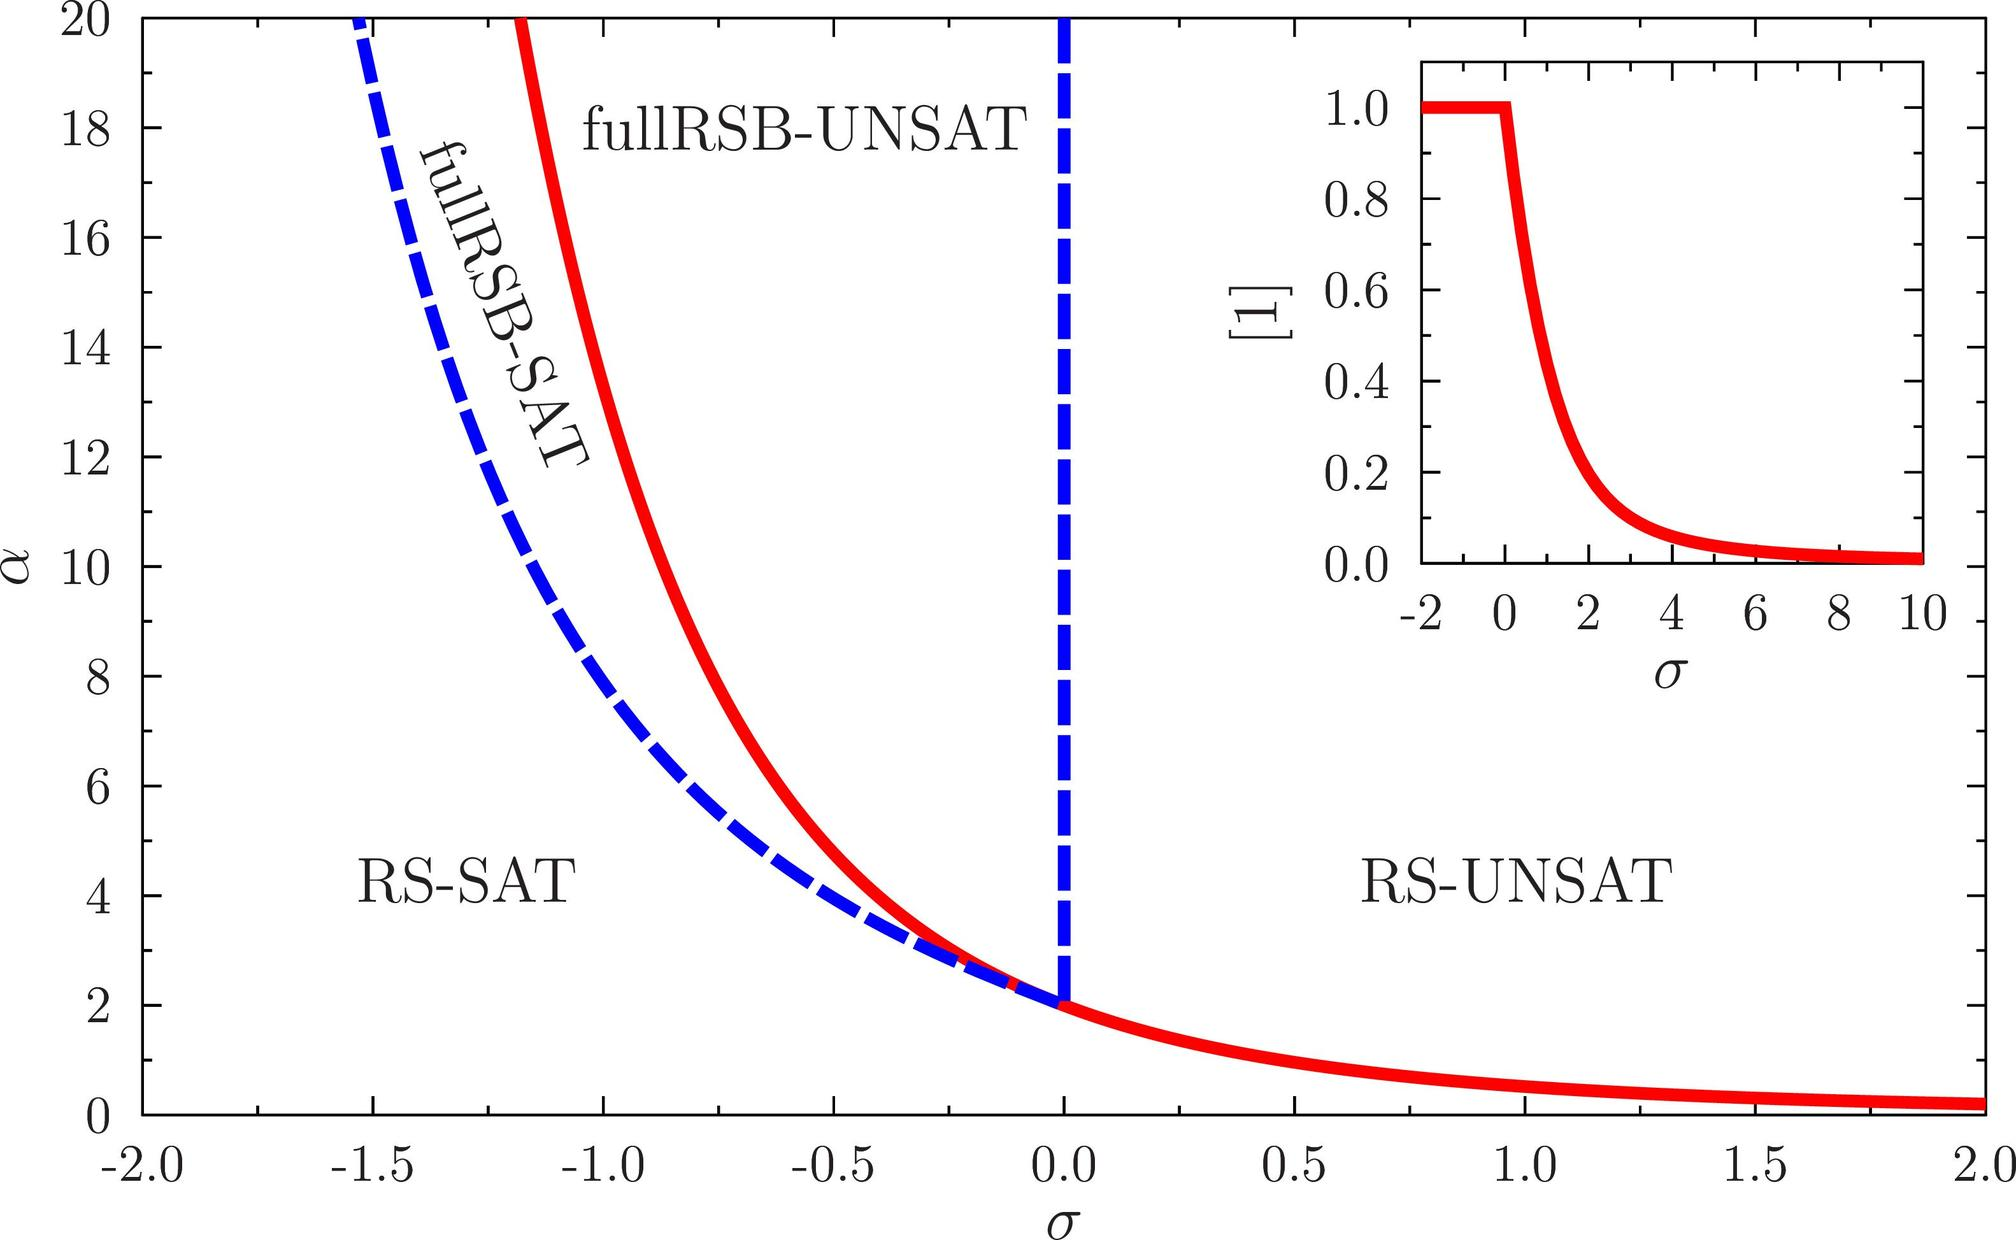Which region of the graph is associated with satisfiable conditions based on the labels provided? A. The region to the left of the blue dashed line B. The region under the red curve C. The region above the red curve D. The region to the right of the blue dashed line The provided graph clearly delineates between regions of satisfiability and unsatisfiability using specific labels and visual cues. Specifically, the region labeled 'RS-SAT' to the left of the blue dashed line indicates where conditions are satisfiable. In contrast, the region to the right, labeled 'fullRSB-UNSAT,' marks conditions as unsatisfiable. Thus, for the question regarding which area is associated with satisfiable conditions, the correct answer is A: The region to the left of the blue dashed line. This assessment is crucial for understanding how parameters like α and σ influence system behaviors in this context. 